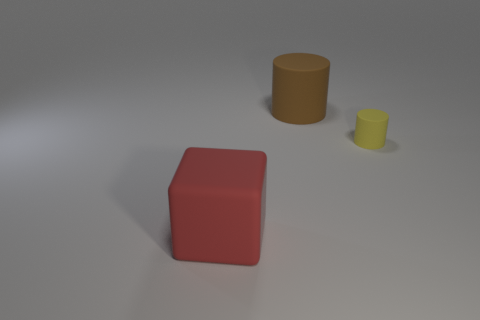Is there any other thing that is the same shape as the big red thing?
Provide a short and direct response. No. Is there anything else that is the same size as the yellow object?
Keep it short and to the point. No. How many balls are tiny objects or big brown objects?
Ensure brevity in your answer.  0. There is a big rubber object in front of the cylinder on the left side of the yellow matte cylinder; what color is it?
Provide a succinct answer. Red. What shape is the tiny yellow matte object?
Offer a very short reply. Cylinder. Is the size of the thing that is behind the yellow matte cylinder the same as the large block?
Offer a terse response. Yes. Is there a tiny cylinder made of the same material as the red block?
Offer a terse response. Yes. What number of things are rubber things right of the red matte thing or red things?
Keep it short and to the point. 3. Are there any tiny green matte things?
Your response must be concise. No. What is the shape of the thing that is both to the left of the tiny yellow rubber cylinder and right of the red rubber cube?
Provide a short and direct response. Cylinder. 